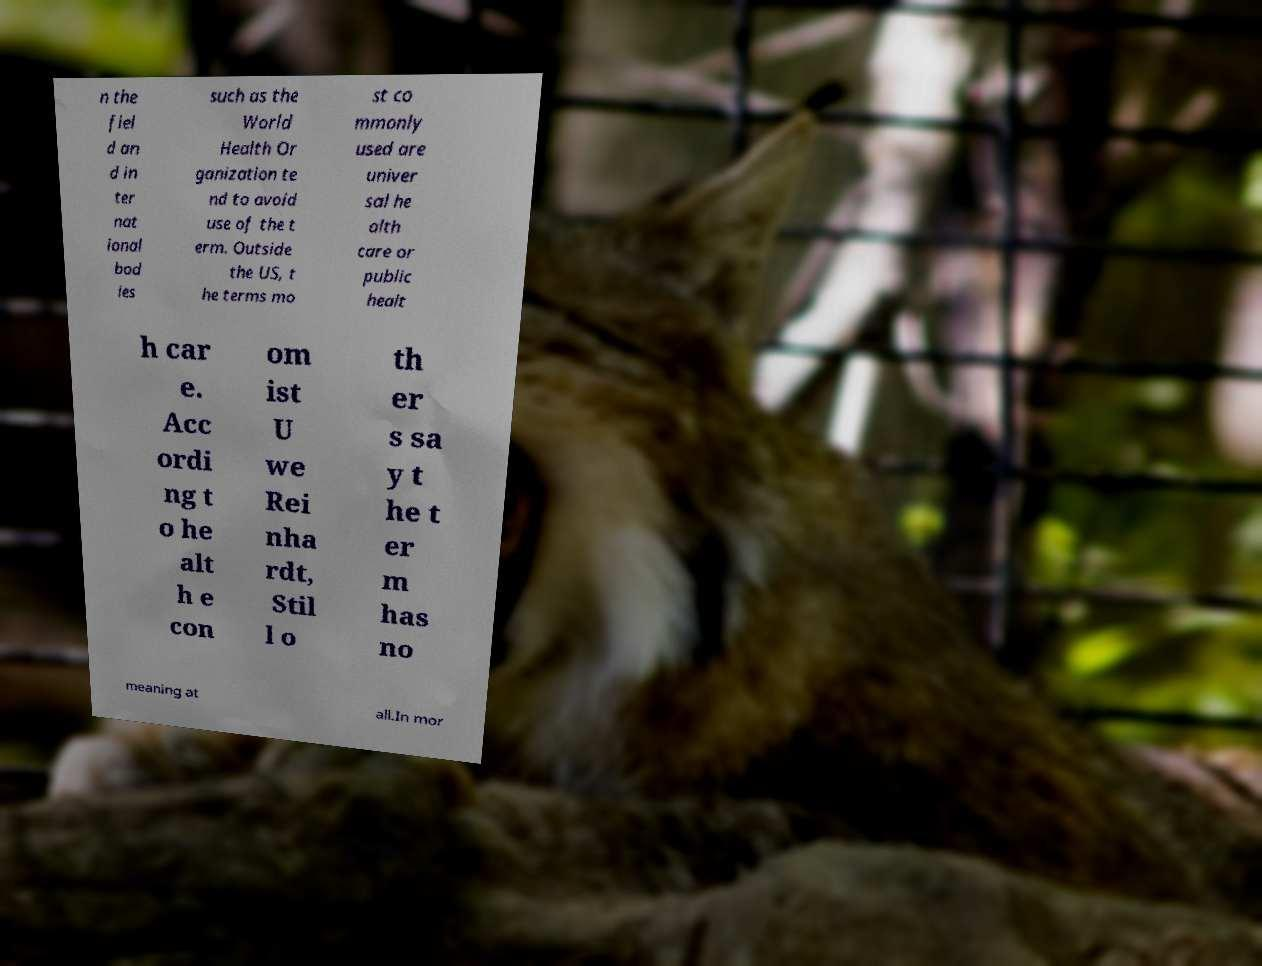Can you accurately transcribe the text from the provided image for me? n the fiel d an d in ter nat ional bod ies such as the World Health Or ganization te nd to avoid use of the t erm. Outside the US, t he terms mo st co mmonly used are univer sal he alth care or public healt h car e. Acc ordi ng t o he alt h e con om ist U we Rei nha rdt, Stil l o th er s sa y t he t er m has no meaning at all.In mor 